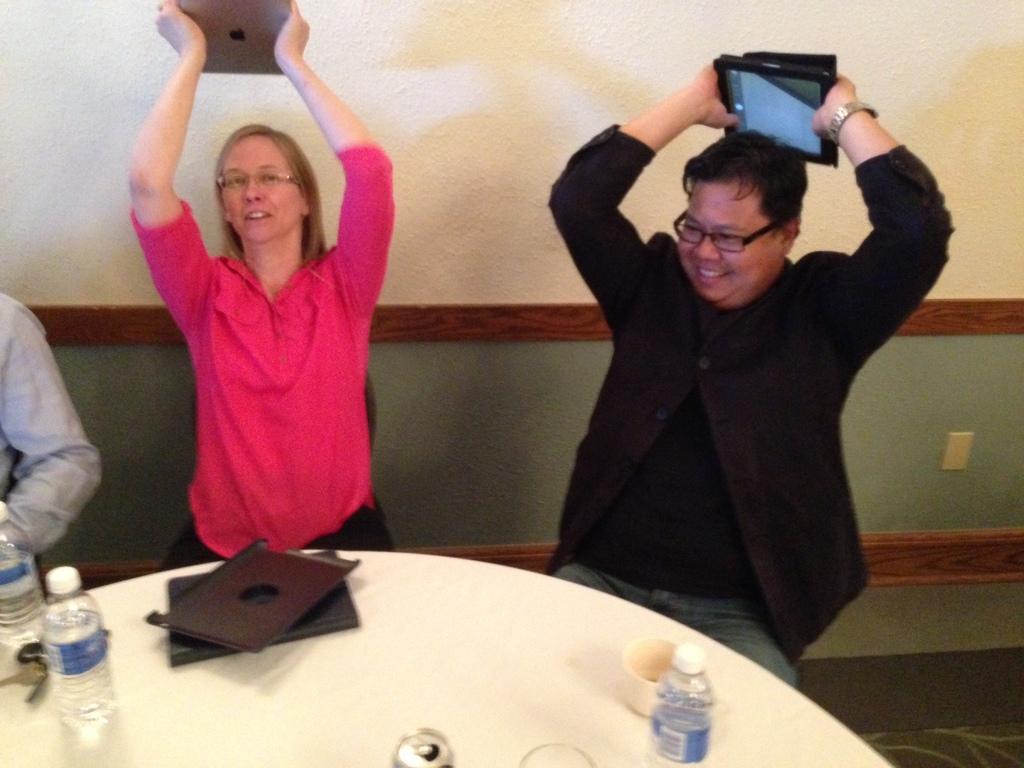Please provide a concise description of this image. In this image we can see a two persons sitting on a chair and they are holding a laptop in their hand. This is table where bottles, a file and a cup are kept on it. 